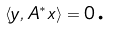<formula> <loc_0><loc_0><loc_500><loc_500>\langle y , A ^ { * } x \rangle = 0 \text {.}</formula> 